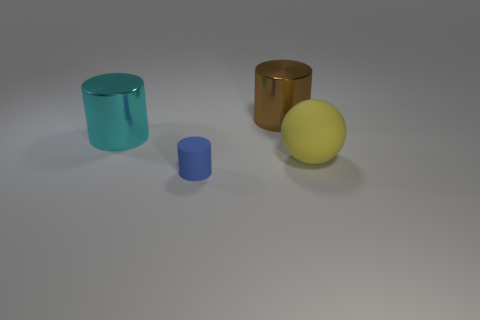Add 3 shiny cylinders. How many objects exist? 7 Subtract all balls. How many objects are left? 3 Add 4 matte balls. How many matte balls exist? 5 Subtract 1 blue cylinders. How many objects are left? 3 Subtract all small blue rubber cylinders. Subtract all red cylinders. How many objects are left? 3 Add 3 brown objects. How many brown objects are left? 4 